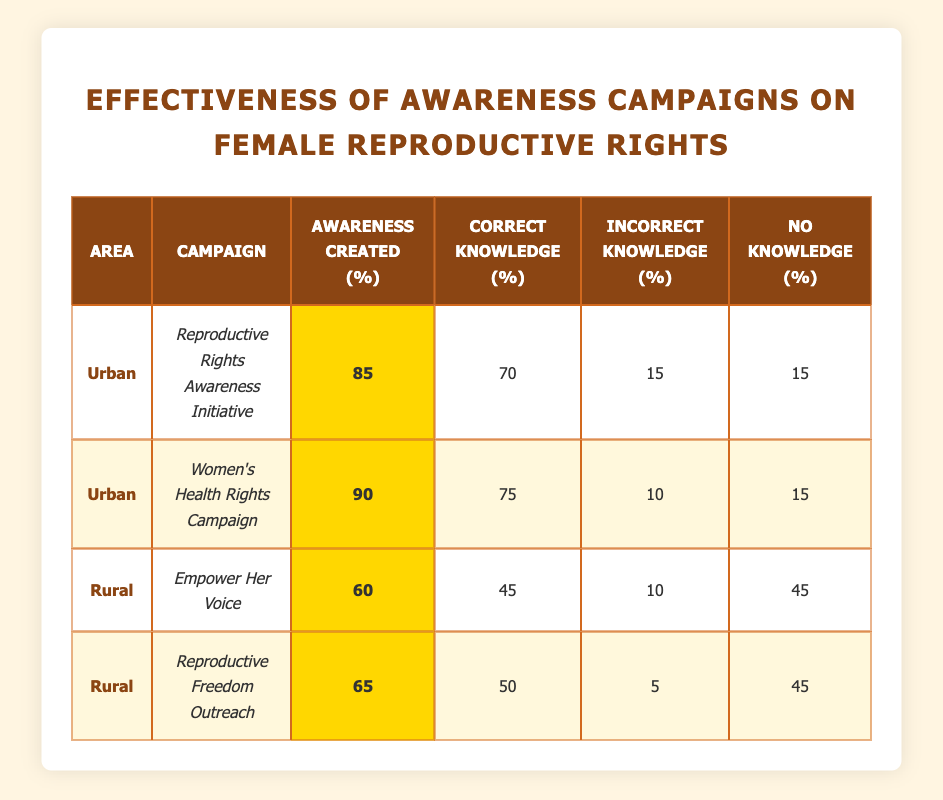What was the highest percentage of awareness created in the urban area? In the urban area, two campaigns were conducted: the Reproductive Rights Awareness Initiative with 85% awareness created and the Women’s Health Rights Campaign with 90% awareness created. Comparing these two values, the highest percentage is 90%.
Answer: 90% What is the total percentage of correct knowledge generated by the campaigns in the rural area? In the rural area, the Empower Her Voice campaign generated 45% correct knowledge and the Reproductive Freedom Outreach campaign generated 50% correct knowledge. Adding these values together gives us 45% + 50% = 95%.
Answer: 95% Did any rural campaign have a higher percentage of incorrect knowledge than the urban campaigns? For the urban campaigns, the highest percentage of incorrect knowledge is 15% (from both urban campaigns). In the rural area, the Empower Her Voice campaign had 10% incorrect knowledge and the Reproductive Freedom Outreach campaign had 5% incorrect knowledge, both of which are less than 15%. Thus, no rural campaign had a higher percentage of incorrect knowledge than the urban campaigns.
Answer: No What is the average percentage of awareness created from all campaigns in the table? To calculate the average percentage of awareness created, we first sum all the awareness percentages: 85% + 90% + 60% + 65% = 300%. There are 4 campaigns, so the average is 300% / 4 = 75%.
Answer: 75% Which campaign created the least awareness in the rural area? The campaigns in the rural area were Empower Her Voice with 60% awareness created and Reproductive Freedom Outreach with 65% awareness created. The Empower Her Voice campaign created the least awareness because 60% is less than 65%.
Answer: Empower Her Voice 